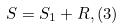Convert formula to latex. <formula><loc_0><loc_0><loc_500><loc_500>S = S _ { 1 } + R , ( 3 )</formula> 